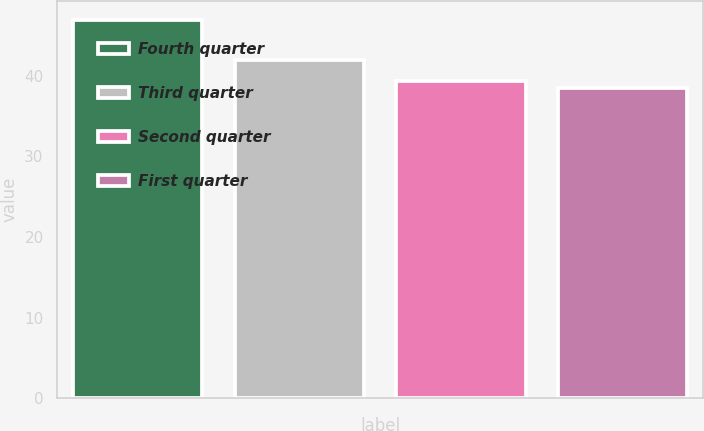Convert chart. <chart><loc_0><loc_0><loc_500><loc_500><bar_chart><fcel>Fourth quarter<fcel>Third quarter<fcel>Second quarter<fcel>First quarter<nl><fcel>46.92<fcel>41.99<fcel>39.32<fcel>38.44<nl></chart> 